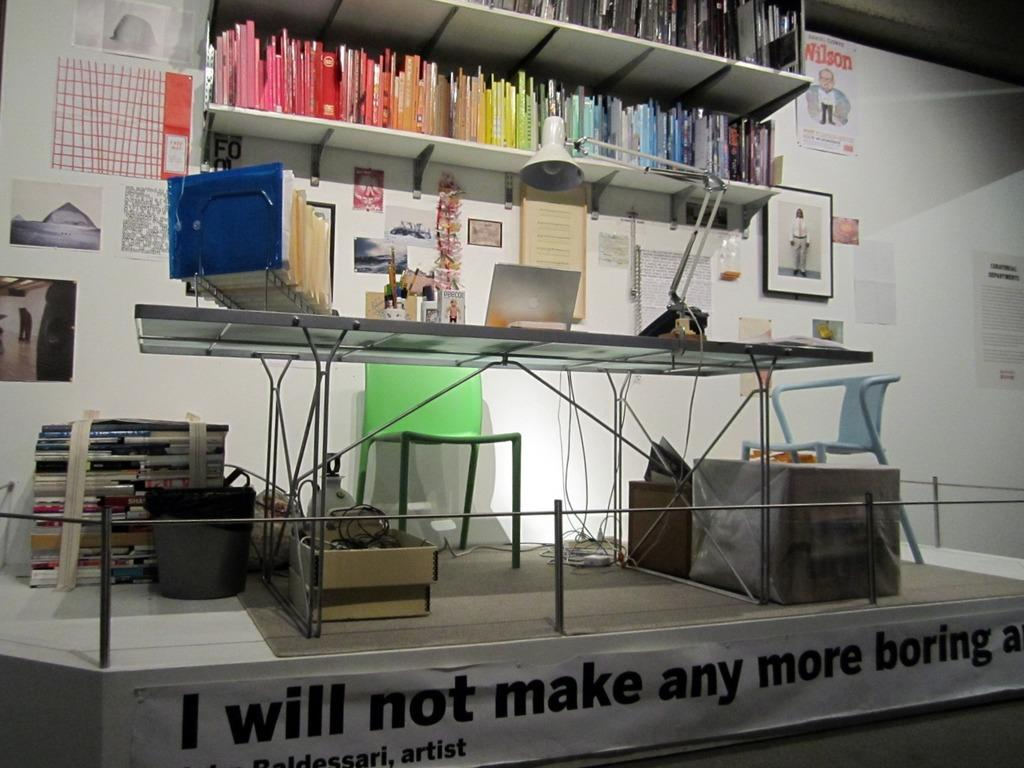<image>
Share a concise interpretation of the image provided. An office set up is displayed with a banner in front of it that says " I will not make any more boring...." 